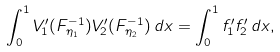Convert formula to latex. <formula><loc_0><loc_0><loc_500><loc_500>\int _ { 0 } ^ { 1 } V _ { 1 } ^ { \prime } ( F _ { \eta _ { 1 } } ^ { - 1 } ) V _ { 2 } ^ { \prime } ( F _ { \eta _ { 2 } } ^ { - 1 } ) \, d x = \int _ { 0 } ^ { 1 } f _ { 1 } ^ { \prime } f _ { 2 } ^ { \prime } \, d x ,</formula> 